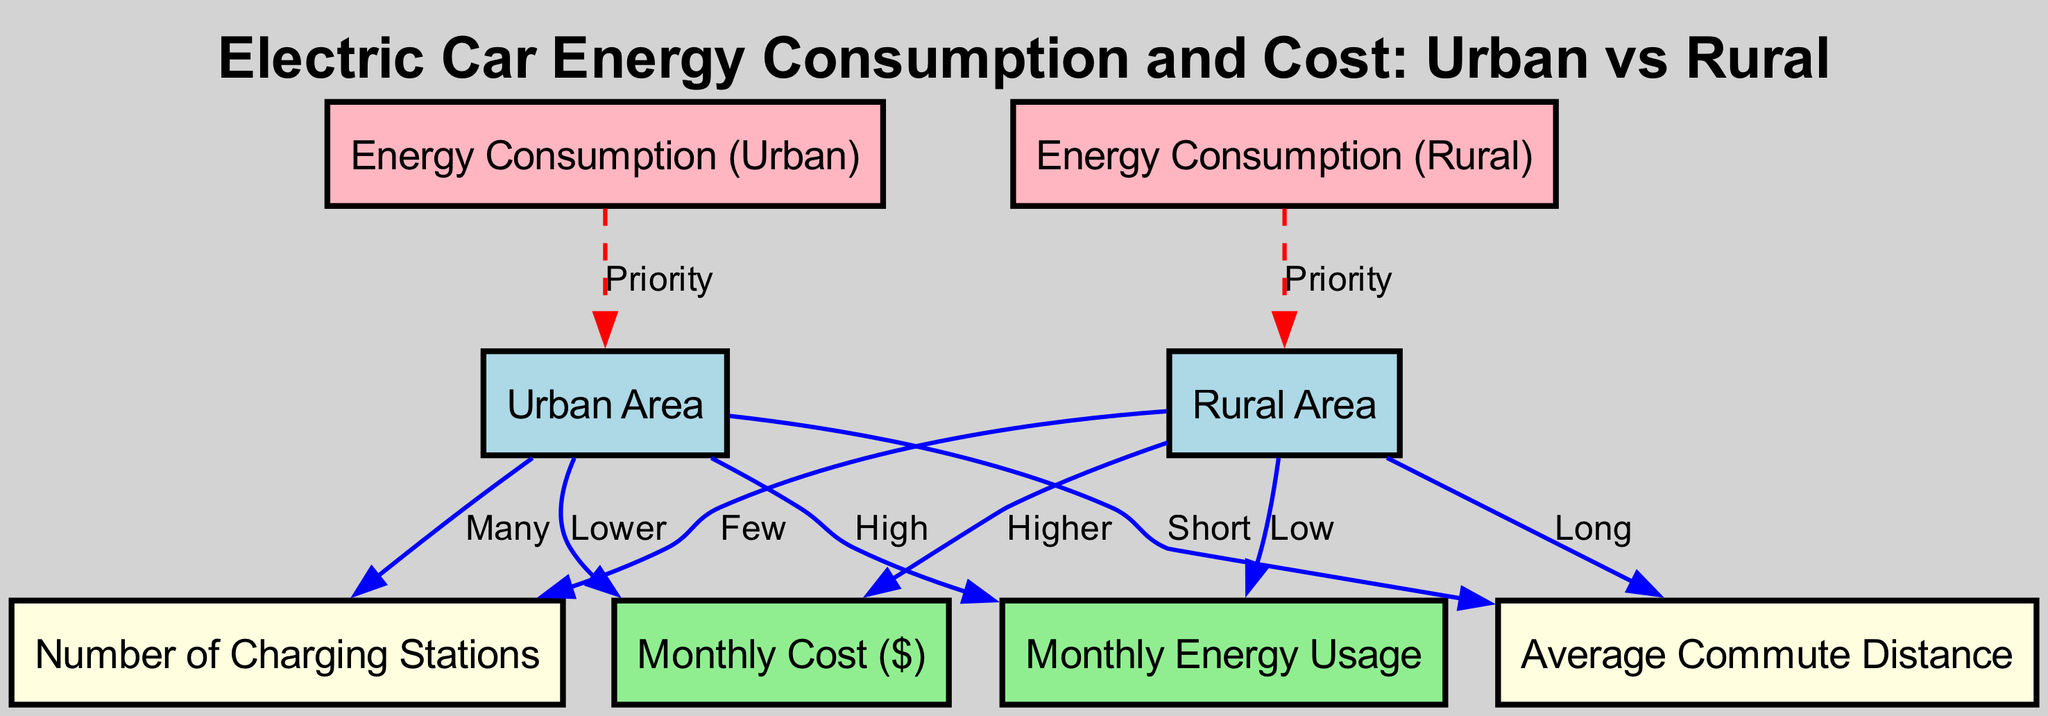What is the energy consumption in urban areas? The diagram indicates the label "High" for energy consumption linked to urban areas, which is represented by the connection from the urban node to the monthly energy usage.
Answer: High What is the monthly cost of operating an electric car in rural areas? The diagram states that rural areas have a connection labeled "Higher" leading to monthly cost, indicating that the cost of operating an electric car in rural regions is comparatively greater than that in urban areas.
Answer: Higher How many charging stations are in urban areas according to the diagram? The diagram shows a connection from the urban node to the charging stations node with the label "Many," which signifies that urban areas have a higher number of charging stations compared to rural areas.
Answer: Many What is the average commute distance in rural areas? The diagram states that the rural area has a label "Long" linked to average commute distance, indicating that commuting distances tend to be longer in rural areas than in urban areas.
Answer: Long Which area has a lower monthly energy usage? By examining the connections in the diagram, it is clear that the rural area is linked to monthly energy usage with the label "Low," indicating that rural areas have lower monthly energy consumption compared to urban areas.
Answer: Rural What is the average commute distance in urban areas? The connection from the urban node to the average commute distance shows the label "Short," indicating that urban areas tend to have shorter commute distances compared to rural areas.
Answer: Short Which area is likely to prioritize energy consumption for electric cars? Both urban and rural nodes have connections to their respective energy consumption nodes labeled "Priority," indicating that energy consumption is a priority in both settings, but they are independently linked.
Answer: Both If you need to charge your electric car, which area has many charging stations? The diagram indicates "Many" charging stations connected to the urban area, implying that urban regions provide a greater number of charging facilities for electric cars.
Answer: Urban What type of areas generally incur a lower monthly cost for electric cars? Based on the connections in the diagram, urban areas have the label "Lower" associated with monthly cost, indicating that it is more economical to operate an electric car in urban areas than in rural ones.
Answer: Urban 